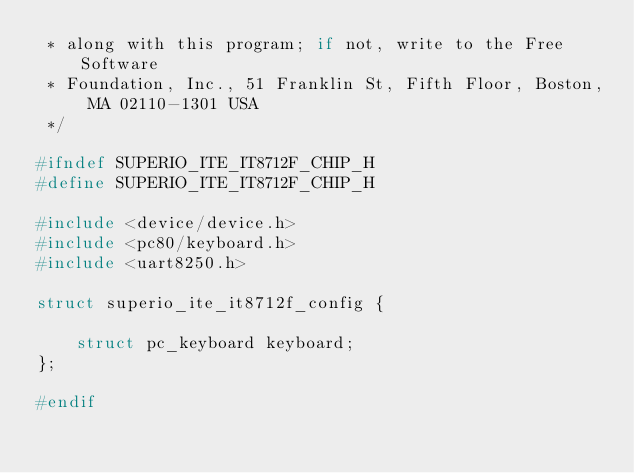Convert code to text. <code><loc_0><loc_0><loc_500><loc_500><_C_> * along with this program; if not, write to the Free Software
 * Foundation, Inc., 51 Franklin St, Fifth Floor, Boston, MA 02110-1301 USA
 */

#ifndef SUPERIO_ITE_IT8712F_CHIP_H
#define SUPERIO_ITE_IT8712F_CHIP_H

#include <device/device.h>
#include <pc80/keyboard.h>
#include <uart8250.h>

struct superio_ite_it8712f_config {

	struct pc_keyboard keyboard;
};

#endif
</code> 